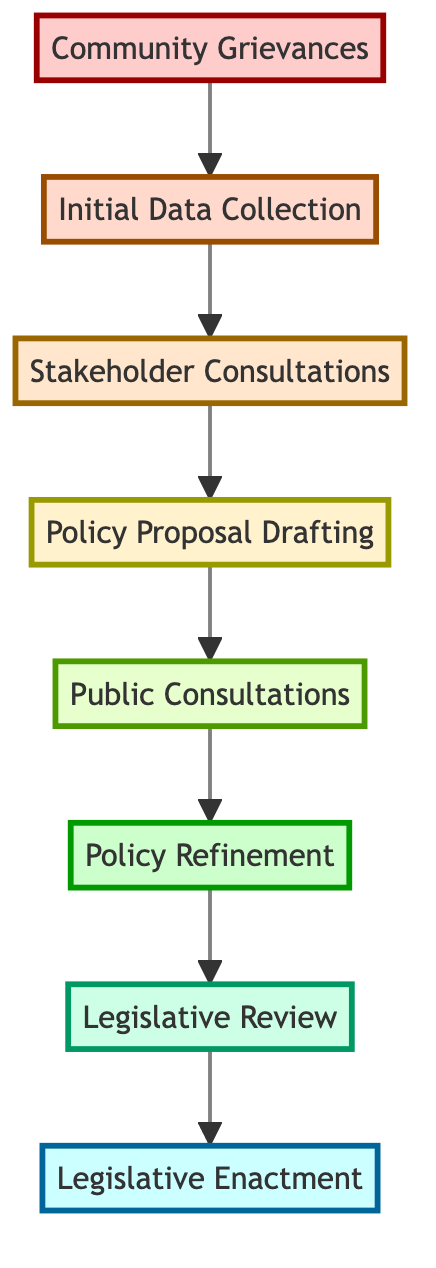What is the final step in this policy reform process? The final step at the top of the flow chart is "Legislative Enactment." This is where the approved policies are enacted into law.
Answer: Legislative Enactment How many levels are there in this diagram? The diagram has eight levels, each representing a distinct stage in the policy reform process from community grievances to legislative enactment.
Answer: Eight Which level involves engaging with key stakeholders? The level that involves engaging with key stakeholders is "Stakeholder Consultations," which is the third level of the diagram.
Answer: Stakeholder Consultations What is the relationship between "Policy Proposal Drafting" and "Public Consultations"? "Policy Proposal Drafting" directly leads to "Public Consultations," indicating that after drafting the proposals, the next step is to consult the public for input.
Answer: Directly leads to What entities are involved in the "Initial Data Collection" step? The entities involved in "Initial Data Collection" include "Survey Agencies," "Research Institutions," and "Municipal Offices," as listed in the second level of the diagram.
Answer: Survey Agencies, Research Institutions, Municipal Offices How do public feedback and expert recommendations impact the policy process? Public feedback and expert recommendations are essential for "Policy Refinement," where the initial proposals are revised and improved based on this input to better reflect community needs and expert insights.
Answer: Policy Refinement What step follows "Public Consultations"? The step that follows "Public Consultations" is "Policy Refinement," where the policy proposals are revised based on the feedback gathered.
Answer: Policy Refinement Which step is directly before "Legislative Review"? The step directly before "Legislative Review" is "Policy Refinement," indicating that the proposals must be refined before they can be reviewed by the legislative body.
Answer: Policy Refinement 